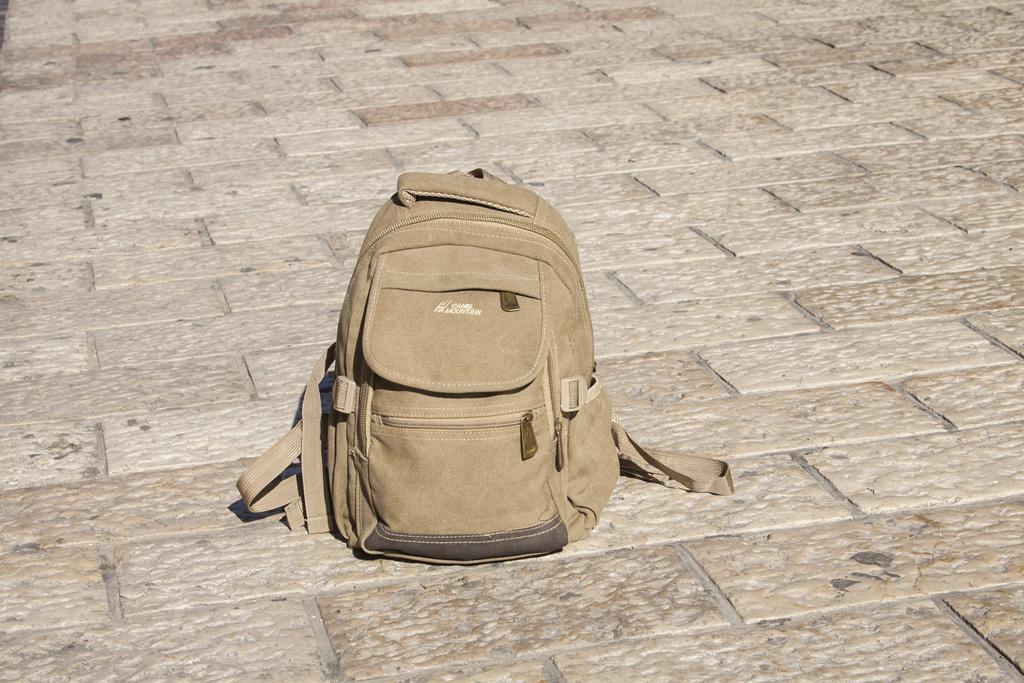Can you describe this image briefly? This is a backpack bag placed on the floor. This bag is light brown in color. It has three zips which are used to open and close the bag. This is a handle at the top of the bag. 